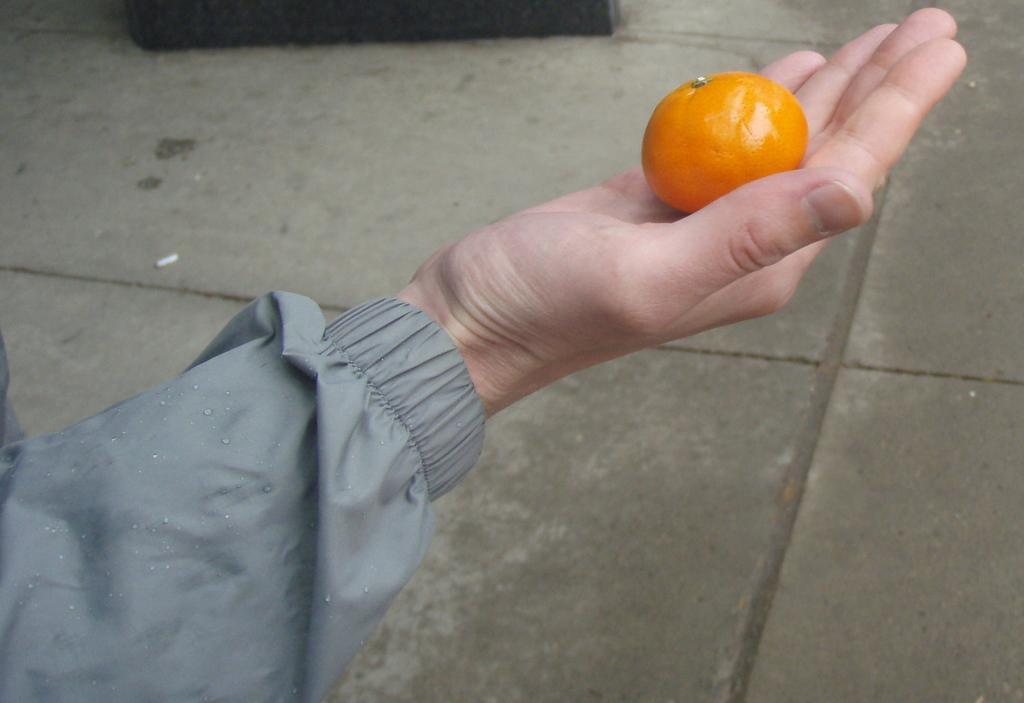Please provide a concise description of this image. In this image I can see a hand of a person and here I can see an orange colour object. 